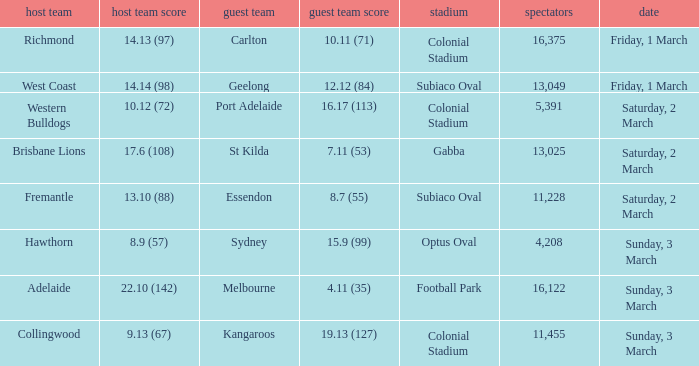What was the ground for away team sydney? Optus Oval. 